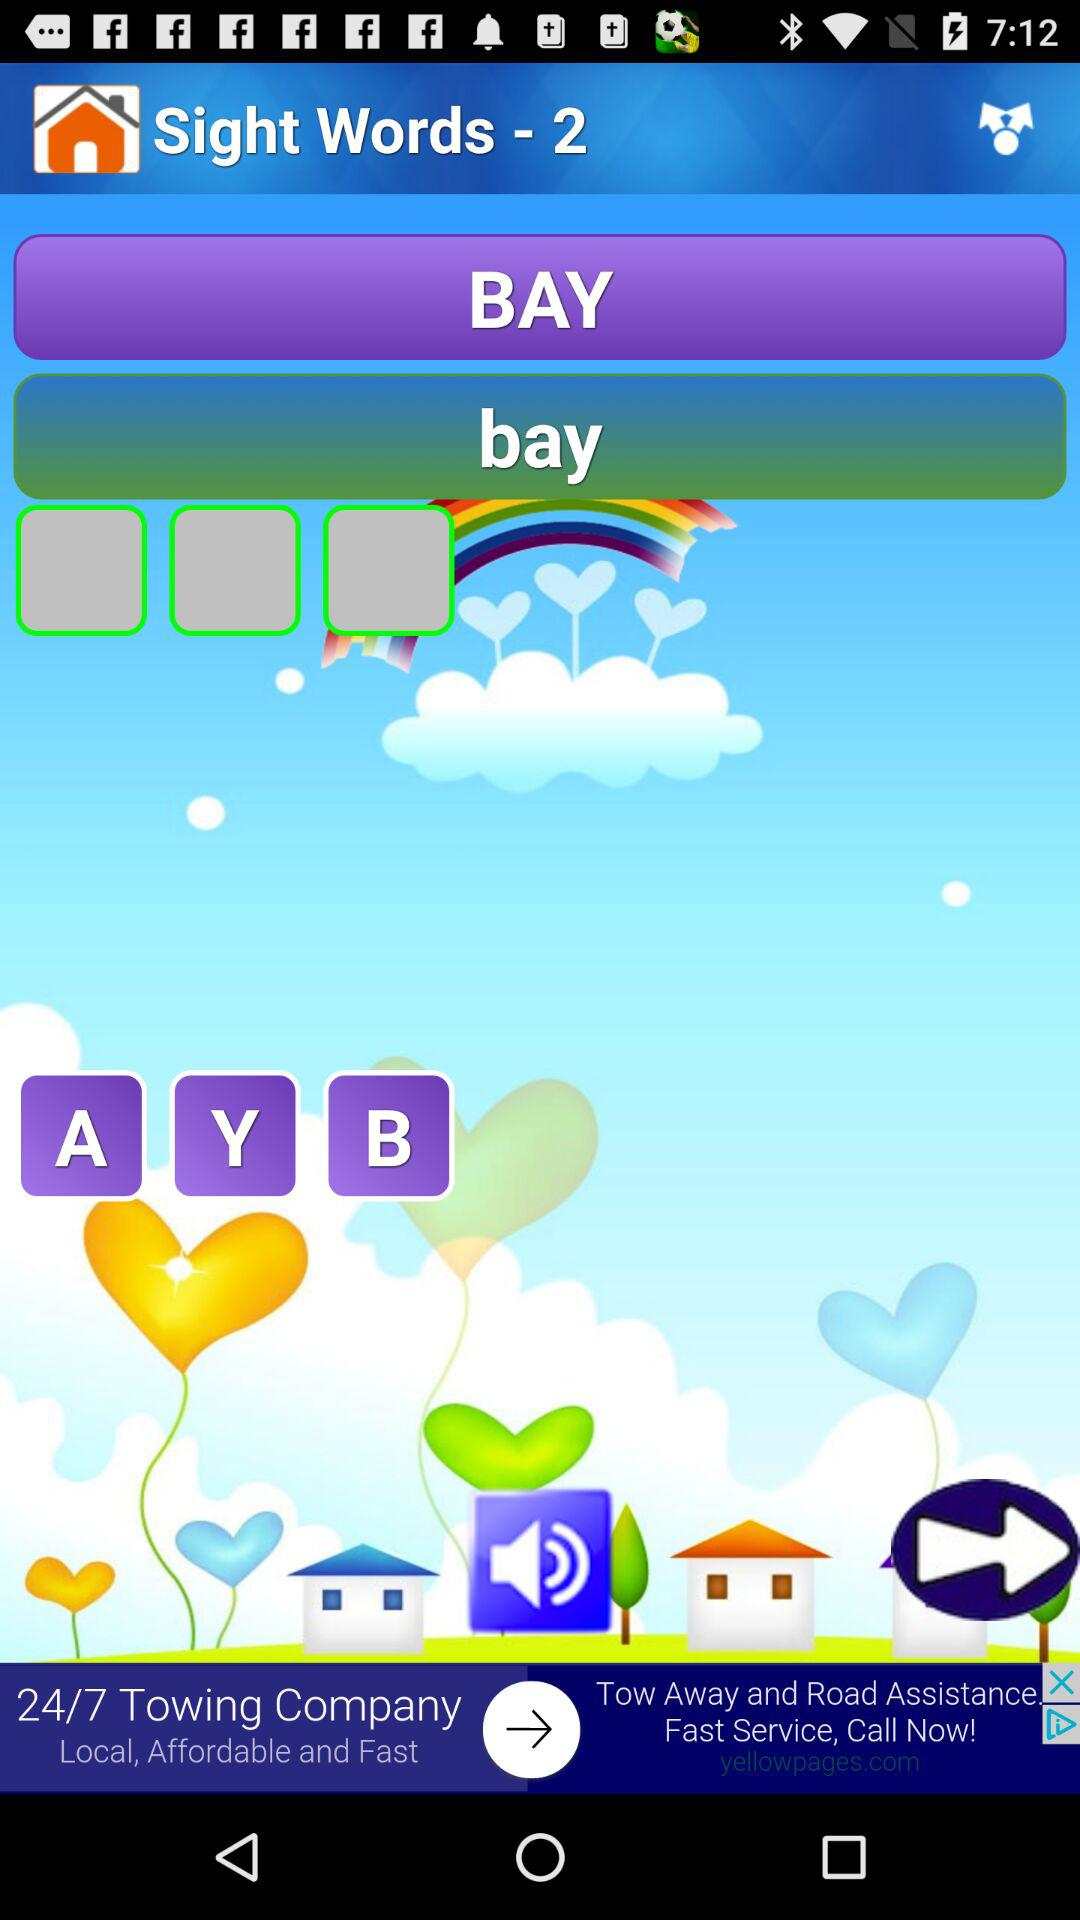What is the name of the application? The application name is "Sight Words - 2". 